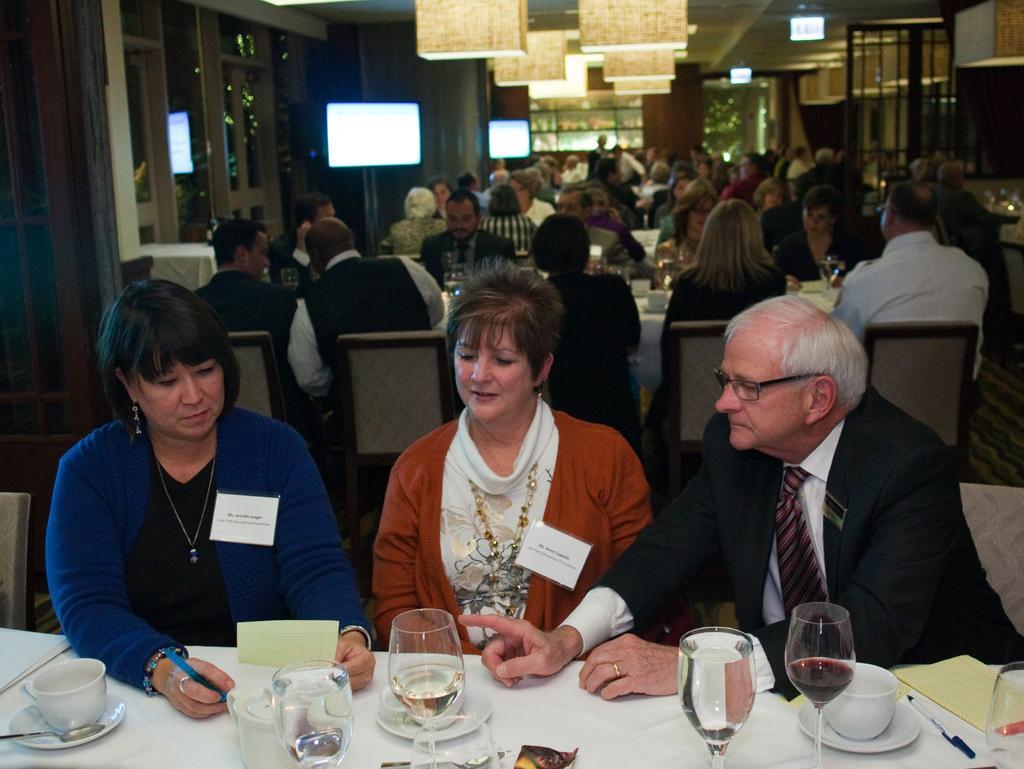In one or two sentences, can you explain what this image depicts? This picture describes about group of people, few are seated and few are standing, in front of them we can see few glasses, cups and some other things on the table, in the left side we can see a woman, she is writing in the paper, in the background we can see few monitors and lights. 